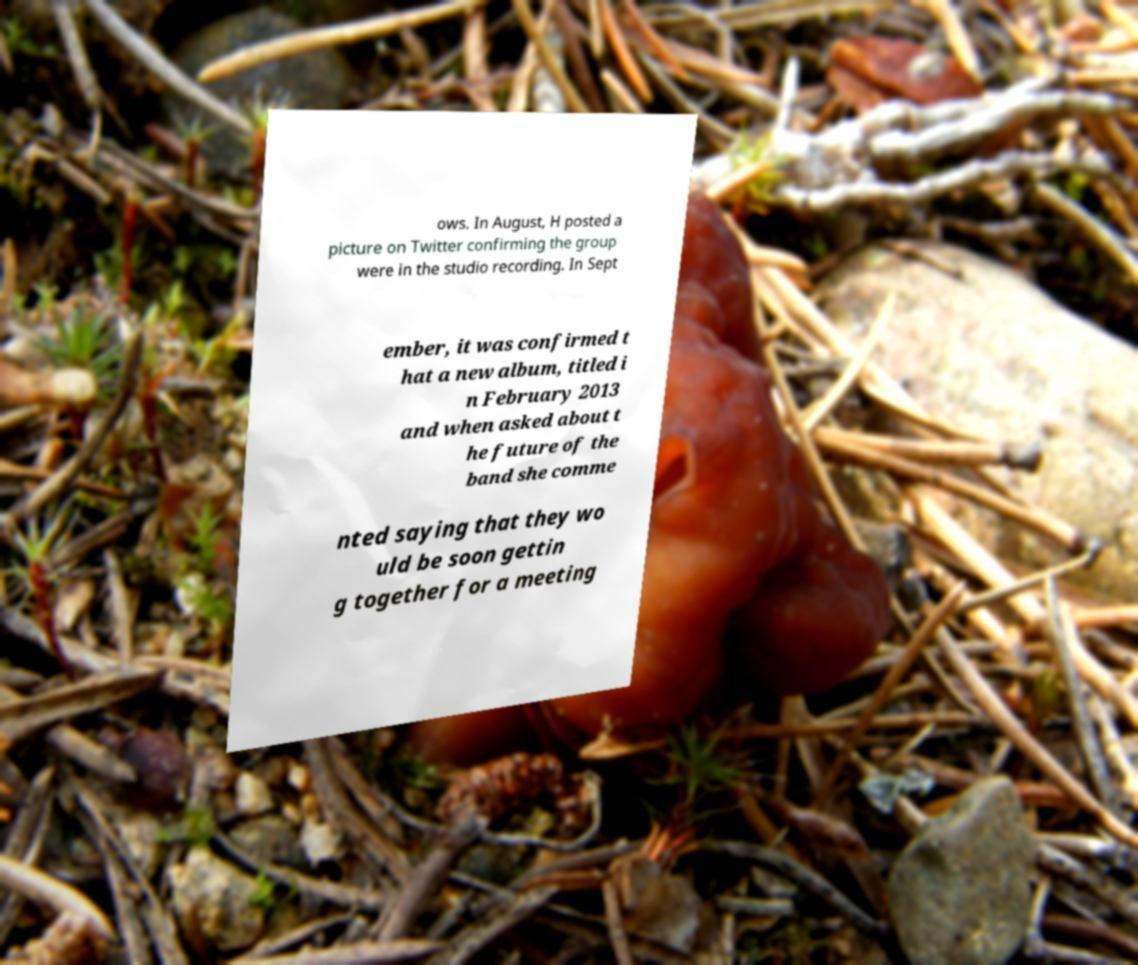Please identify and transcribe the text found in this image. ows. In August, H posted a picture on Twitter confirming the group were in the studio recording. In Sept ember, it was confirmed t hat a new album, titled i n February 2013 and when asked about t he future of the band she comme nted saying that they wo uld be soon gettin g together for a meeting 